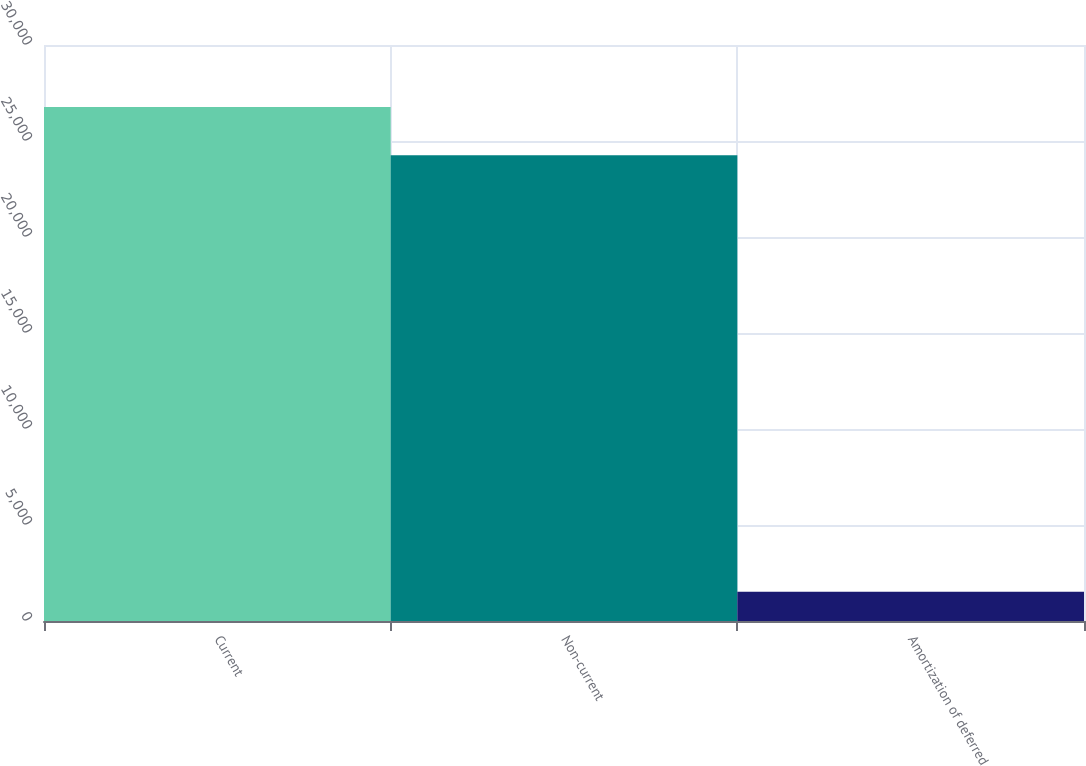<chart> <loc_0><loc_0><loc_500><loc_500><bar_chart><fcel>Current<fcel>Non-current<fcel>Amortization of deferred<nl><fcel>26764.6<fcel>24256<fcel>1518<nl></chart> 